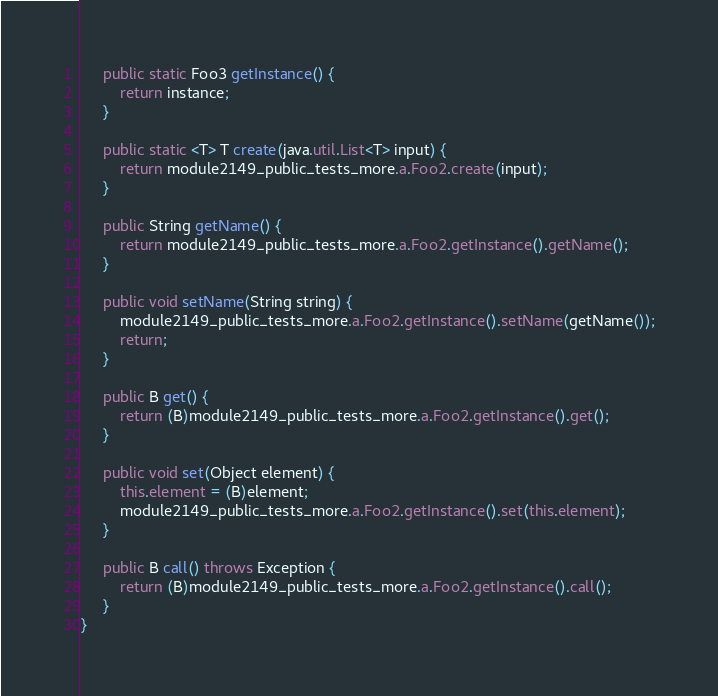<code> <loc_0><loc_0><loc_500><loc_500><_Java_>
	 public static Foo3 getInstance() {
	 	 return instance;
	 }

	 public static <T> T create(java.util.List<T> input) {
	 	 return module2149_public_tests_more.a.Foo2.create(input);
	 }

	 public String getName() {
	 	 return module2149_public_tests_more.a.Foo2.getInstance().getName();
	 }

	 public void setName(String string) {
	 	 module2149_public_tests_more.a.Foo2.getInstance().setName(getName());
	 	 return;
	 }

	 public B get() {
	 	 return (B)module2149_public_tests_more.a.Foo2.getInstance().get();
	 }

	 public void set(Object element) {
	 	 this.element = (B)element;
	 	 module2149_public_tests_more.a.Foo2.getInstance().set(this.element);
	 }

	 public B call() throws Exception {
	 	 return (B)module2149_public_tests_more.a.Foo2.getInstance().call();
	 }
}
</code> 